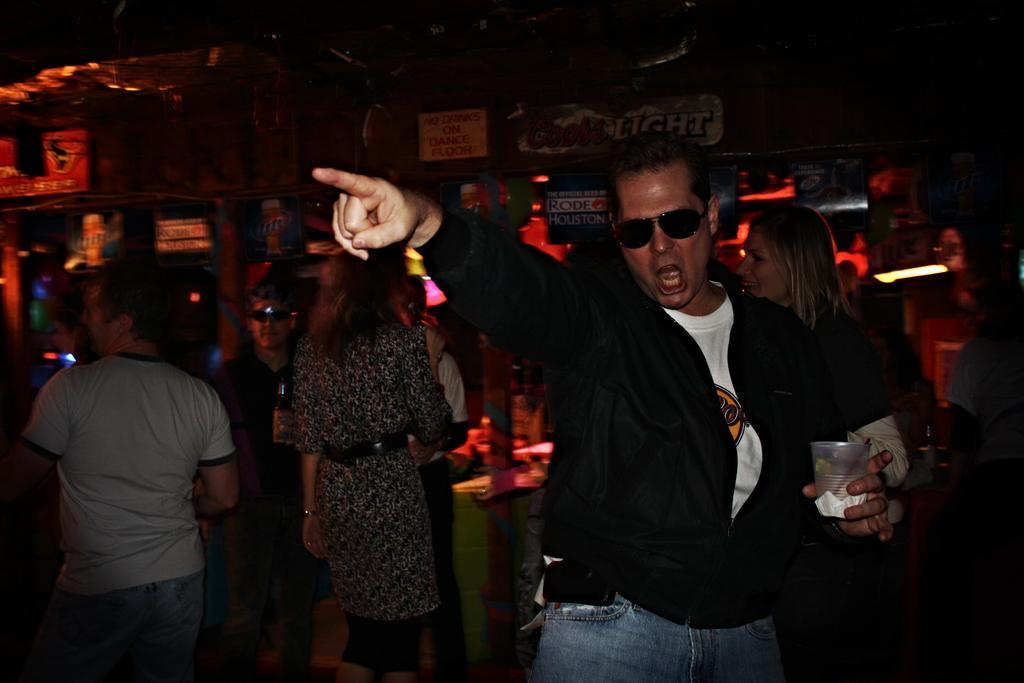How would you summarize this image in a sentence or two? In this image I see a man over here and I see that he is wearing black jacket, white t-shirt and blue jeans and he is holding a glass in his hand and I see that he is wearing black shades. In the background I see few more people and I see that it is a bit dark. 